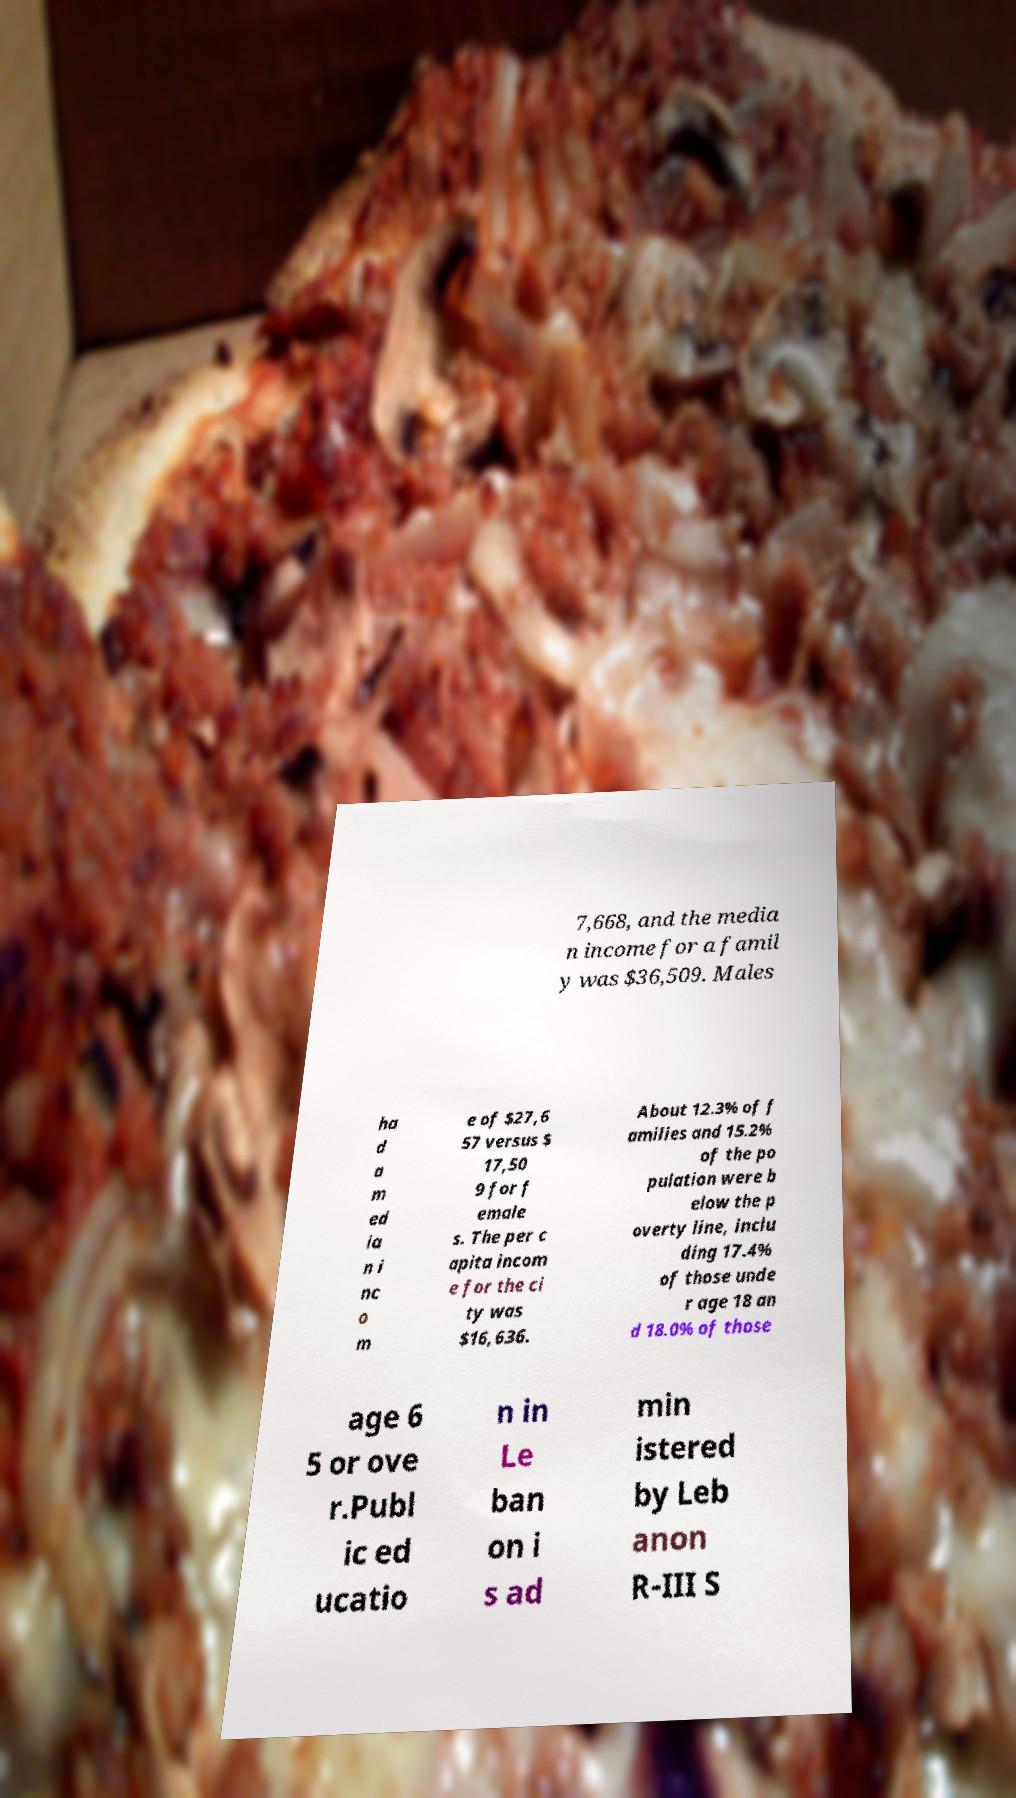I need the written content from this picture converted into text. Can you do that? 7,668, and the media n income for a famil y was $36,509. Males ha d a m ed ia n i nc o m e of $27,6 57 versus $ 17,50 9 for f emale s. The per c apita incom e for the ci ty was $16,636. About 12.3% of f amilies and 15.2% of the po pulation were b elow the p overty line, inclu ding 17.4% of those unde r age 18 an d 18.0% of those age 6 5 or ove r.Publ ic ed ucatio n in Le ban on i s ad min istered by Leb anon R-III S 